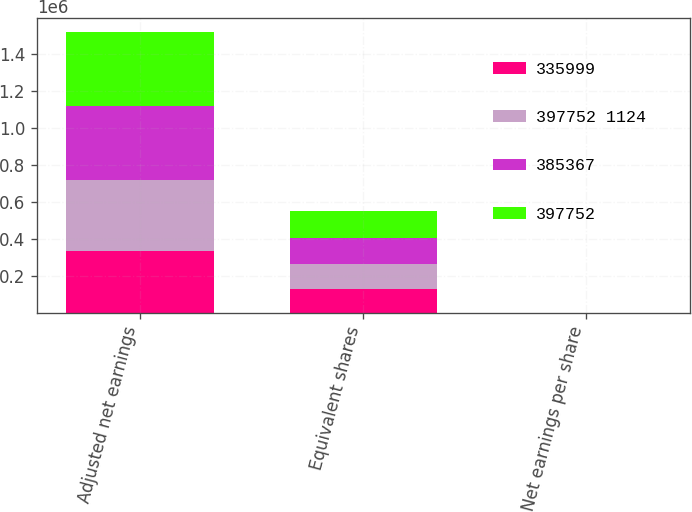<chart> <loc_0><loc_0><loc_500><loc_500><stacked_bar_chart><ecel><fcel>Adjusted net earnings<fcel>Equivalent shares<fcel>Net earnings per share<nl><fcel>335999<fcel>335999<fcel>130067<fcel>2.58<nl><fcel>397752 1124<fcel>385367<fcel>133823<fcel>2.88<nl><fcel>385367<fcel>397752<fcel>139079<fcel>2.86<nl><fcel>397752<fcel>398876<fcel>145670<fcel>2.74<nl></chart> 